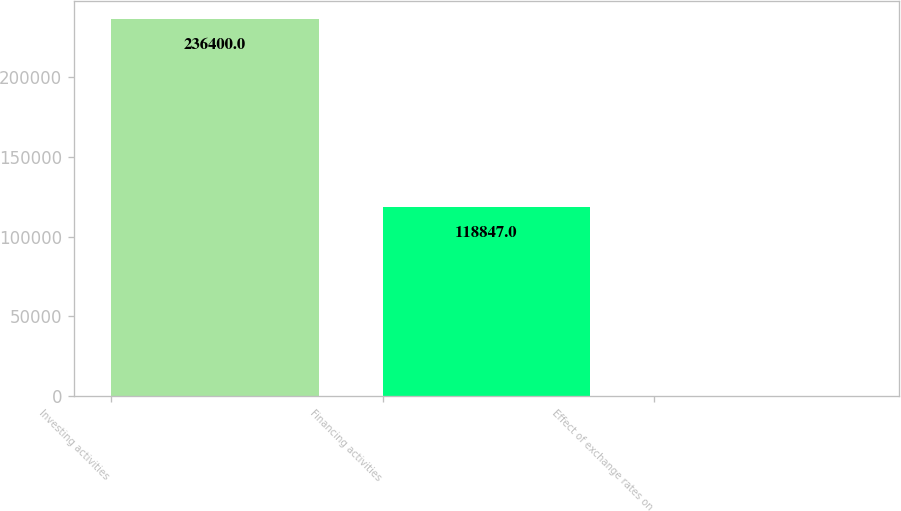Convert chart. <chart><loc_0><loc_0><loc_500><loc_500><bar_chart><fcel>Investing activities<fcel>Financing activities<fcel>Effect of exchange rates on<nl><fcel>236400<fcel>118847<fcel>301<nl></chart> 